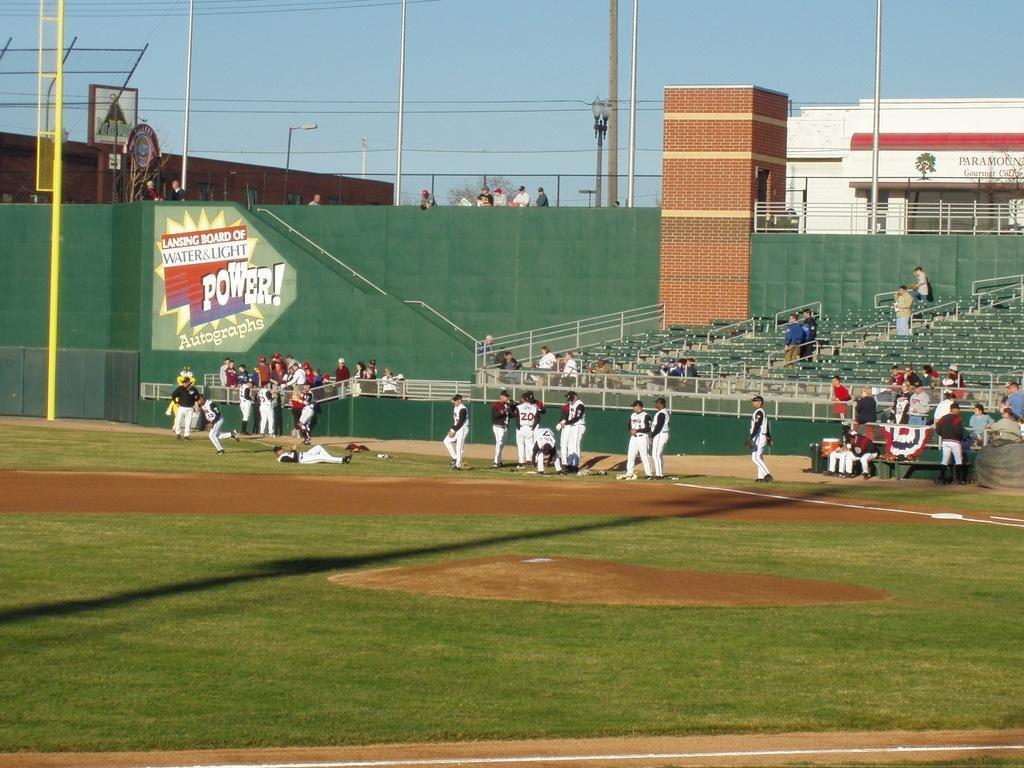Could you give a brief overview of what you see in this image? In this image we can see many players wearing white dresses are on the ground. Here we can see a few people in the stadium, green color wall, the brick wall, a few people standing here, we can see building, light poles, trees and the sky in the background. 